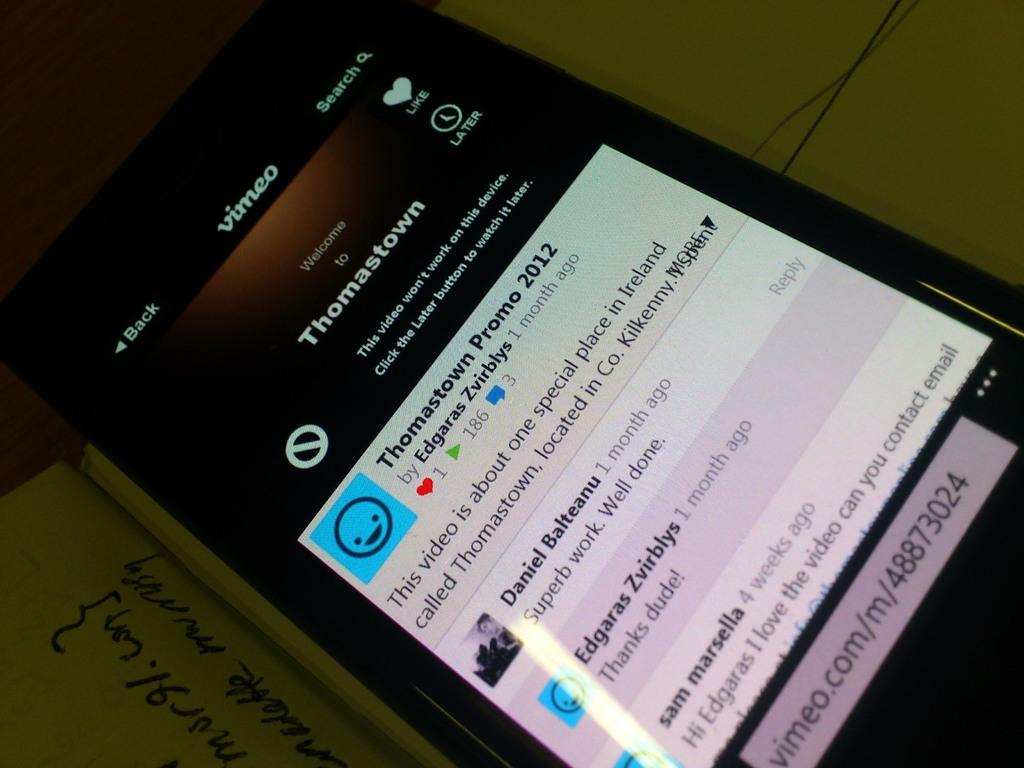What brand is the cell phone?
Make the answer very short. Unanswerable. What app are they using?
Your answer should be compact. Vimeo. 